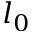<formula> <loc_0><loc_0><loc_500><loc_500>l _ { 0 }</formula> 